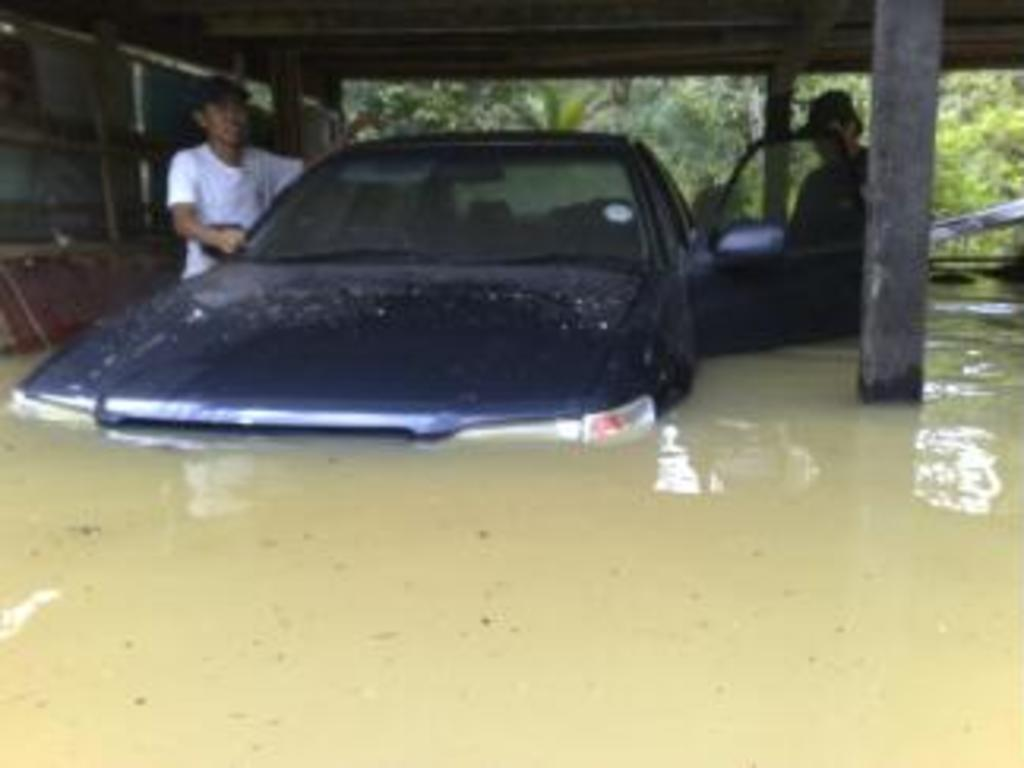What is the main subject of the image? The main subject of the image is a car in the water. Are there any people present in the image? Yes, there are people standing near the water. What type of structures can be seen in the image? There are pillars visible in the image, as well as a shed. What type of pollution is visible in the water near the car? There is no visible pollution in the water near the car in the image. What type of jeans are the people wearing near the water? The provided facts do not mention the type of clothing the people are wearing, so we cannot determine if they are wearing jeans or any other type of clothing. 